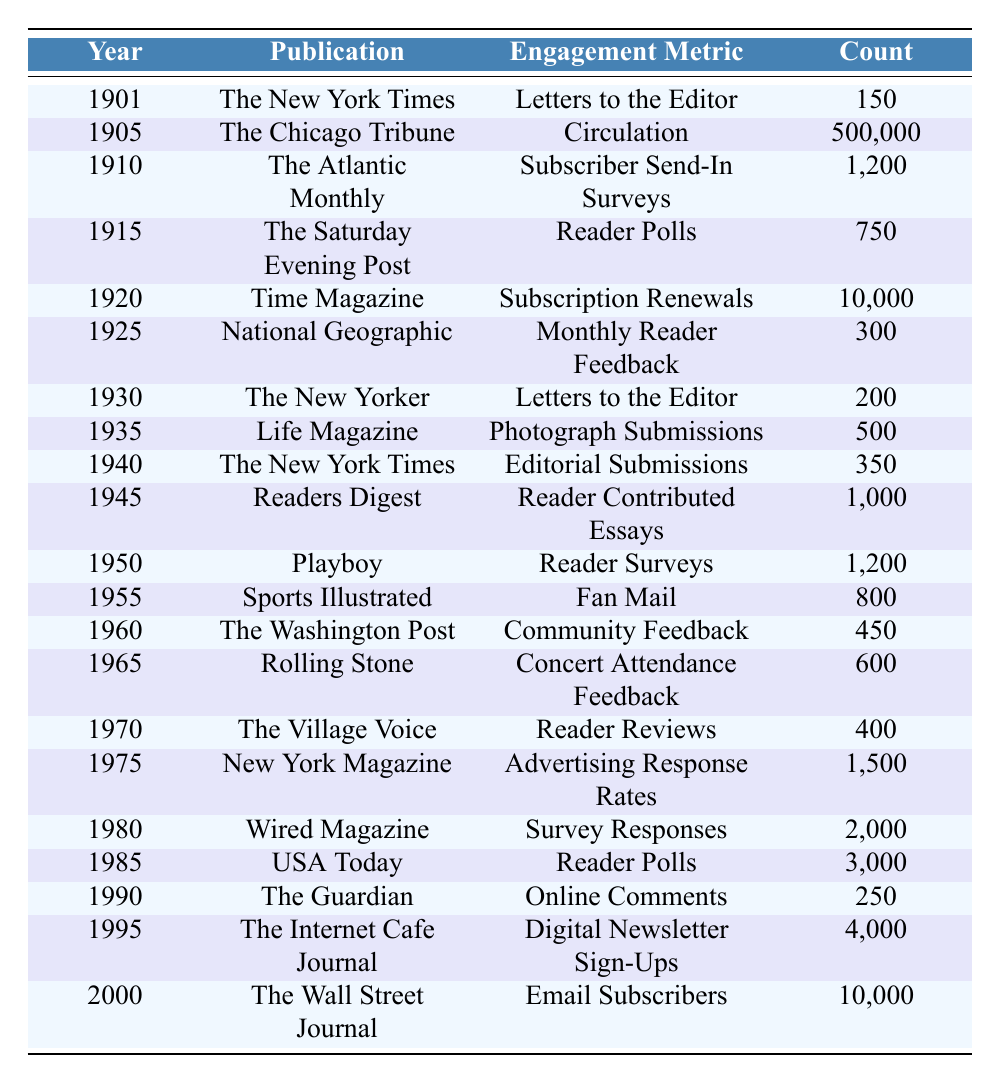What was the highest engagement metric count recorded in the table? The highest engagement metric is 500,000 recorded for "Circulation" in "The Chicago Tribune" in 1905. By examining each publication's engagement metrics, we find that the number for The Chicago Tribune is the largest.
Answer: 500,000 How many total reader polls were recorded for publications from 1900 to 2000? The two publications that recorded reader polls are "The Saturday Evening Post" with 750 and "USA Today" with 3,000. Summing these gives 750 + 3000 = 3750.
Answer: 3750 Which publication had the lowest engagement metric count? "The Guardian" had the lowest engagement metric count of 250 for "Online Comments" in 1990, when comparing all counts listed in the table.
Answer: 250 What was the difference between the engagement metrics of "Time Magazine" in 1920 and "The Wall Street Journal" in 2000? "Time Magazine" had an engagement metric count of 10,000 in 1920 and "The Wall Street Journal" had 10,000 in 2000. Therefore, 10,000 - 10,000 = 0, indicating no difference in their engagement contributions.
Answer: 0 What publication had “Digital Newsletter Sign-Ups” as its engagement metric, and what was the count? "The Internet Cafe Journal" had "Digital Newsletter Sign-Ups" as its engagement metric with a count of 4,000 recorded in 1995. Looking at the publications and metrics, we find this specific entry.
Answer: "The Internet Cafe Journal," 4,000 How many publications have an engagement metric count greater than 2,000? "Wired Magazine" (2,000), "USA Today" (3,000), and "Digital Newsletter Sign-Ups" from "The Internet Cafe Journal" (4,000) meet this criterion. Counting these gives a total of 3 publications.
Answer: 3 Which year had the most significant increase in engagement metric count compared to the previous one? Comparing the counts year by year, "The Internet Cafe Journal” in 1995 with 4,000 is a significant increase over earlier years, most notably increasing from 1,500 in 1975 to 2,000 in 1980, which is a relatively moderate increase. If considering jumps, from 1955 to 1980 is an increase from 800 to 2,000; hence overall, the steepest single increase occurs from 1950 with 1,200, showing past decades of lower growth compared to 1990.
Answer: 4,000 in 1995 Which publication had more engagement metrics related to readership over the years: "The New York Times" or "USA Today"? "The New York Times" has varied metrics like "Letters to the Editor” and “Editorial Submissions," with counts of 150 and 350 respectively, totaling to 500, whereas "USA Today" has "Reader Polls" at 3,000. Hence, comparing counts shows "USA Today" had a higher individual engagement reader count for its polls compared to those of “The New York Times."
Answer: "USA Today" 